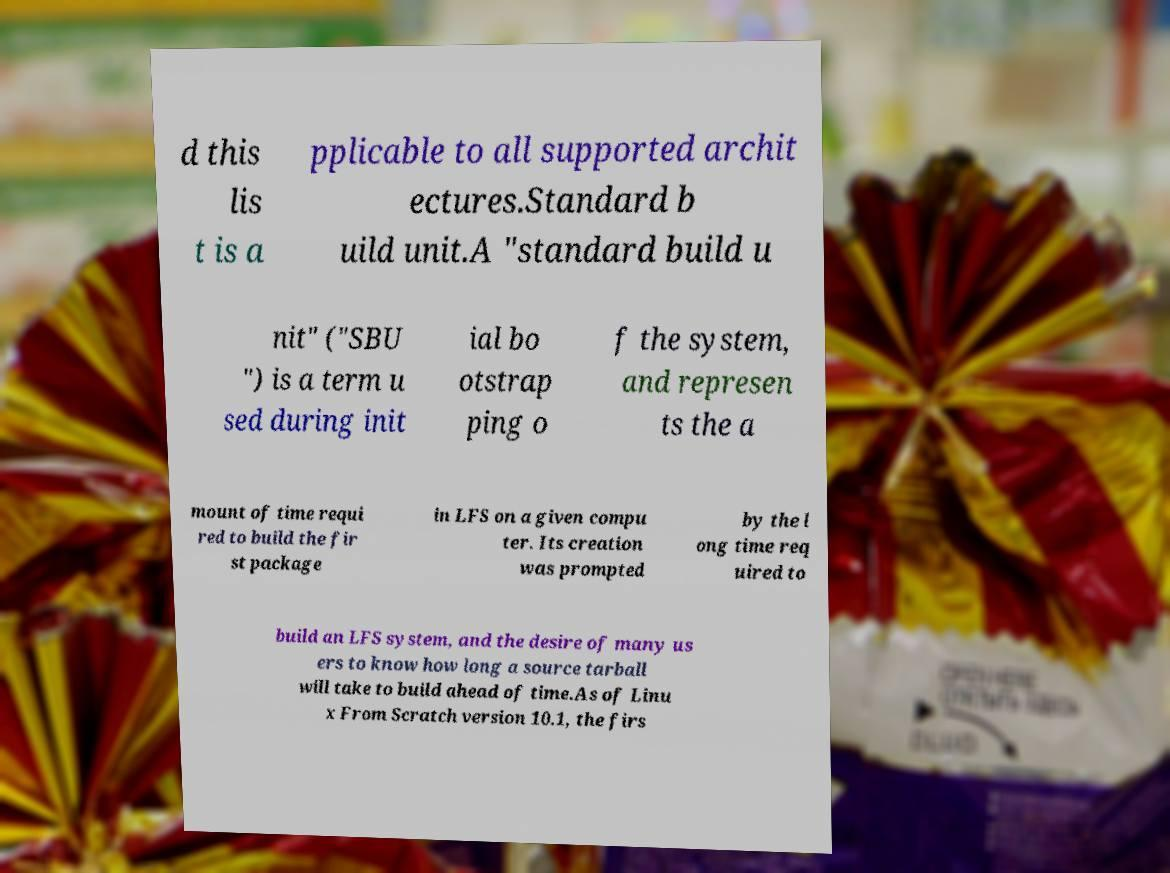Please identify and transcribe the text found in this image. d this lis t is a pplicable to all supported archit ectures.Standard b uild unit.A "standard build u nit" ("SBU ") is a term u sed during init ial bo otstrap ping o f the system, and represen ts the a mount of time requi red to build the fir st package in LFS on a given compu ter. Its creation was prompted by the l ong time req uired to build an LFS system, and the desire of many us ers to know how long a source tarball will take to build ahead of time.As of Linu x From Scratch version 10.1, the firs 